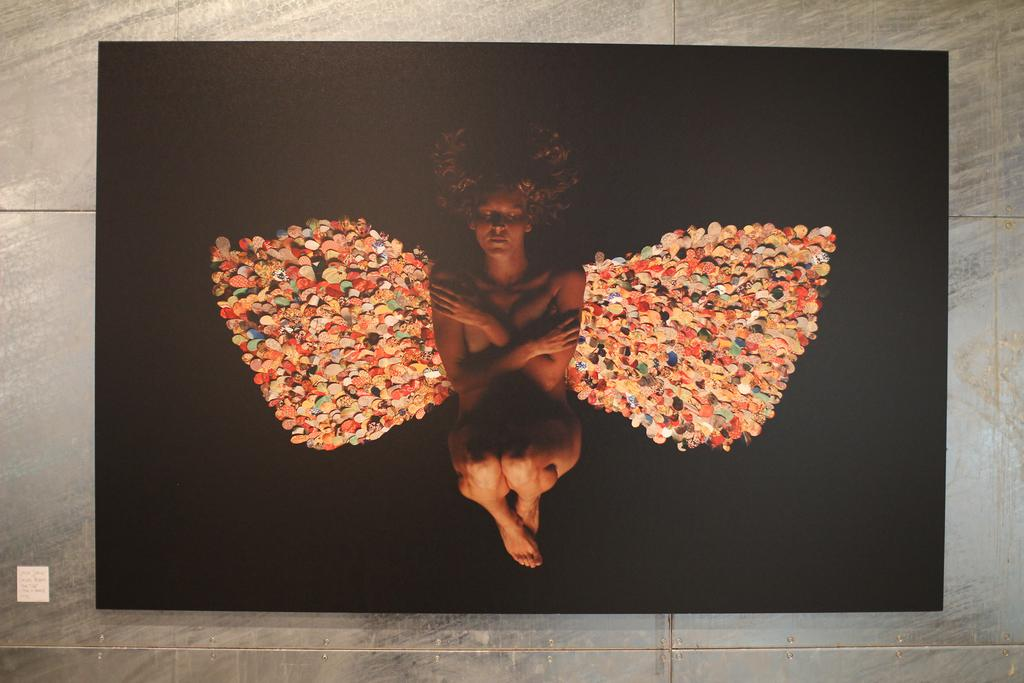What is the main subject of the image? There is a picture in the image. What can be seen in the picture? There is a person in the middle of the picture. What is visible in the background of the picture? There is a wall and tiles in the background of the picture. What type of veil is covering the person in the image? There is no veil present in the image; the person is not covered by any fabric. What material is the leather item in the image made of? There is no leather item present in the image. 